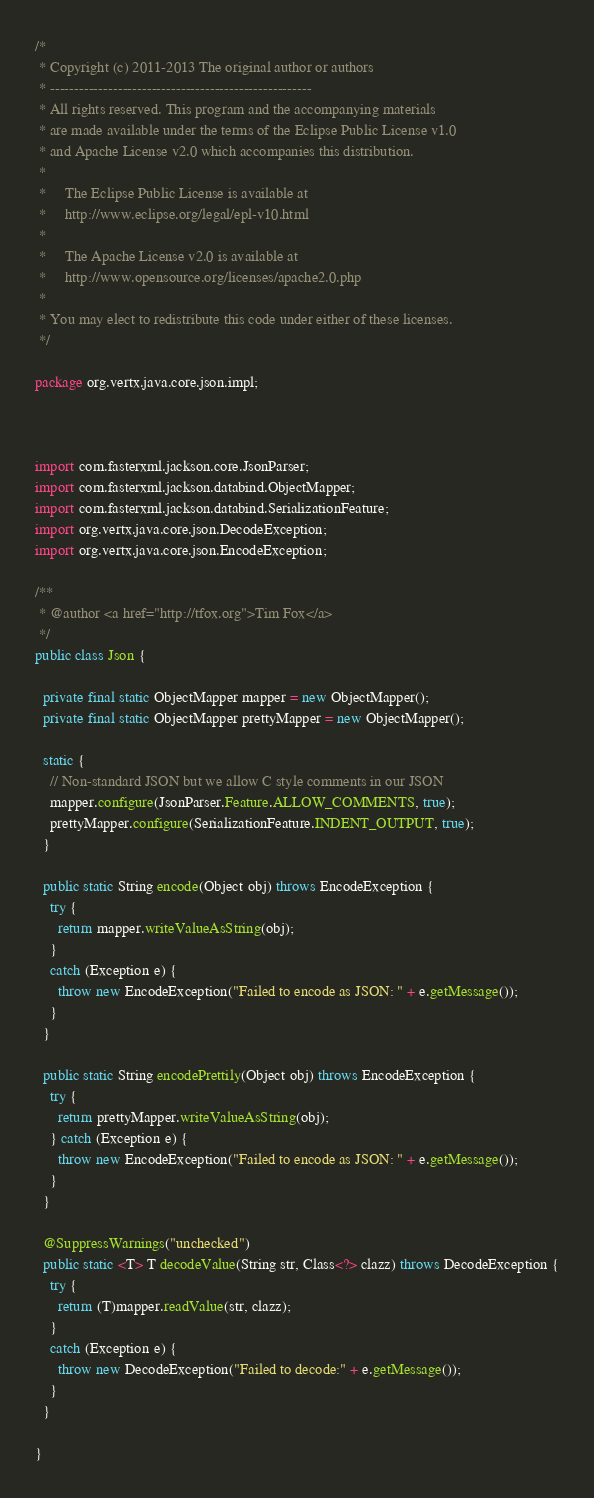Convert code to text. <code><loc_0><loc_0><loc_500><loc_500><_Java_>/*
 * Copyright (c) 2011-2013 The original author or authors
 * ------------------------------------------------------
 * All rights reserved. This program and the accompanying materials
 * are made available under the terms of the Eclipse Public License v1.0
 * and Apache License v2.0 which accompanies this distribution.
 *
 *     The Eclipse Public License is available at
 *     http://www.eclipse.org/legal/epl-v10.html
 *
 *     The Apache License v2.0 is available at
 *     http://www.opensource.org/licenses/apache2.0.php
 *
 * You may elect to redistribute this code under either of these licenses.
 */

package org.vertx.java.core.json.impl;



import com.fasterxml.jackson.core.JsonParser;
import com.fasterxml.jackson.databind.ObjectMapper;
import com.fasterxml.jackson.databind.SerializationFeature;
import org.vertx.java.core.json.DecodeException;
import org.vertx.java.core.json.EncodeException;

/**
 * @author <a href="http://tfox.org">Tim Fox</a>
 */
public class Json {

  private final static ObjectMapper mapper = new ObjectMapper();
  private final static ObjectMapper prettyMapper = new ObjectMapper();

  static {
    // Non-standard JSON but we allow C style comments in our JSON
    mapper.configure(JsonParser.Feature.ALLOW_COMMENTS, true);
    prettyMapper.configure(SerializationFeature.INDENT_OUTPUT, true);
  }

  public static String encode(Object obj) throws EncodeException {
    try {
      return mapper.writeValueAsString(obj);
    }
    catch (Exception e) {
      throw new EncodeException("Failed to encode as JSON: " + e.getMessage());
    }
  }

  public static String encodePrettily(Object obj) throws EncodeException {
    try {
      return prettyMapper.writeValueAsString(obj);
    } catch (Exception e) {
      throw new EncodeException("Failed to encode as JSON: " + e.getMessage());
    }
  }

  @SuppressWarnings("unchecked")
  public static <T> T decodeValue(String str, Class<?> clazz) throws DecodeException {
    try {
      return (T)mapper.readValue(str, clazz);
    }
    catch (Exception e) {
      throw new DecodeException("Failed to decode:" + e.getMessage());
    }
  }

}
</code> 